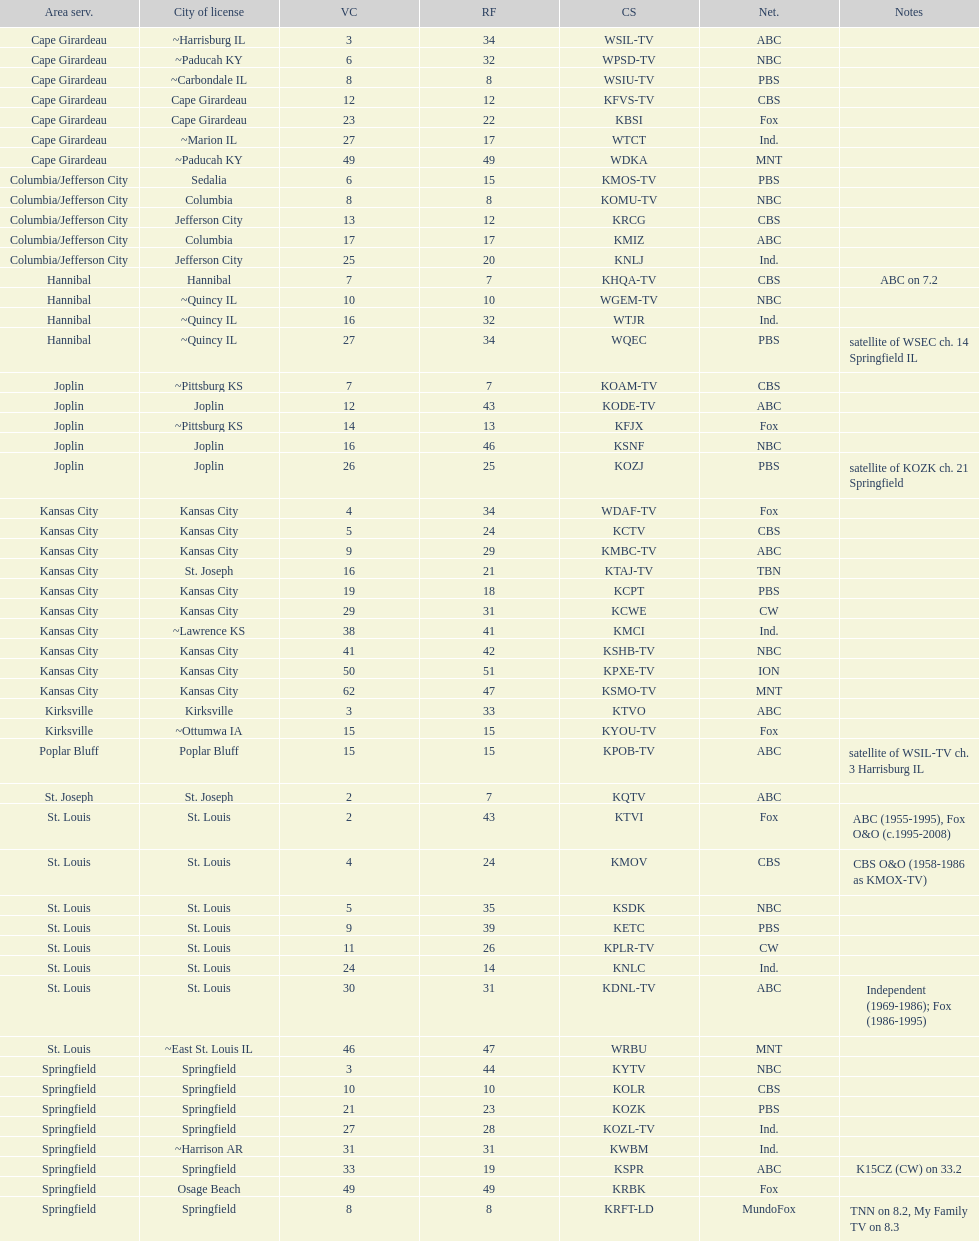Which station is licensed in the same city as koam-tv? KFJX. 